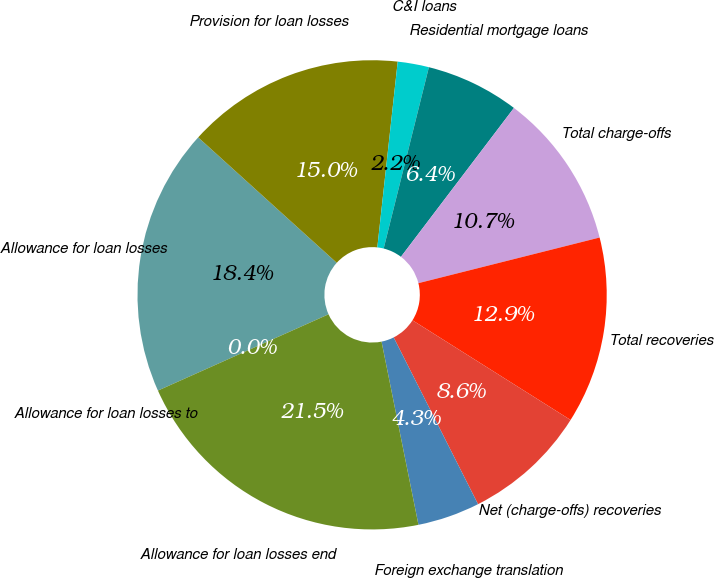<chart> <loc_0><loc_0><loc_500><loc_500><pie_chart><fcel>Allowance for loan losses<fcel>Provision for loan losses<fcel>C&I loans<fcel>Residential mortgage loans<fcel>Total charge-offs<fcel>Total recoveries<fcel>Net (charge-offs) recoveries<fcel>Foreign exchange translation<fcel>Allowance for loan losses end<fcel>Allowance for loan losses to<nl><fcel>18.4%<fcel>15.03%<fcel>2.15%<fcel>6.44%<fcel>10.74%<fcel>12.88%<fcel>8.59%<fcel>4.29%<fcel>21.47%<fcel>0.0%<nl></chart> 